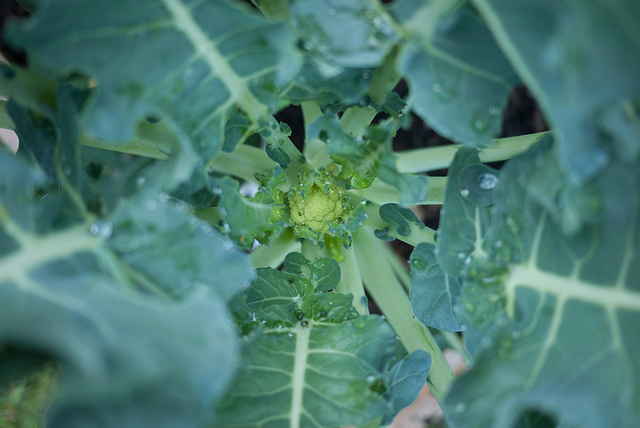<image>Will this plant produce a cruciferous vegetable? I don't know if this plant will produce a cruciferous vegetable. The answer could be yes or no. Will this plant produce a cruciferous vegetable? I don't know if this plant will produce a cruciferous vegetable. It can be both yes or no. 